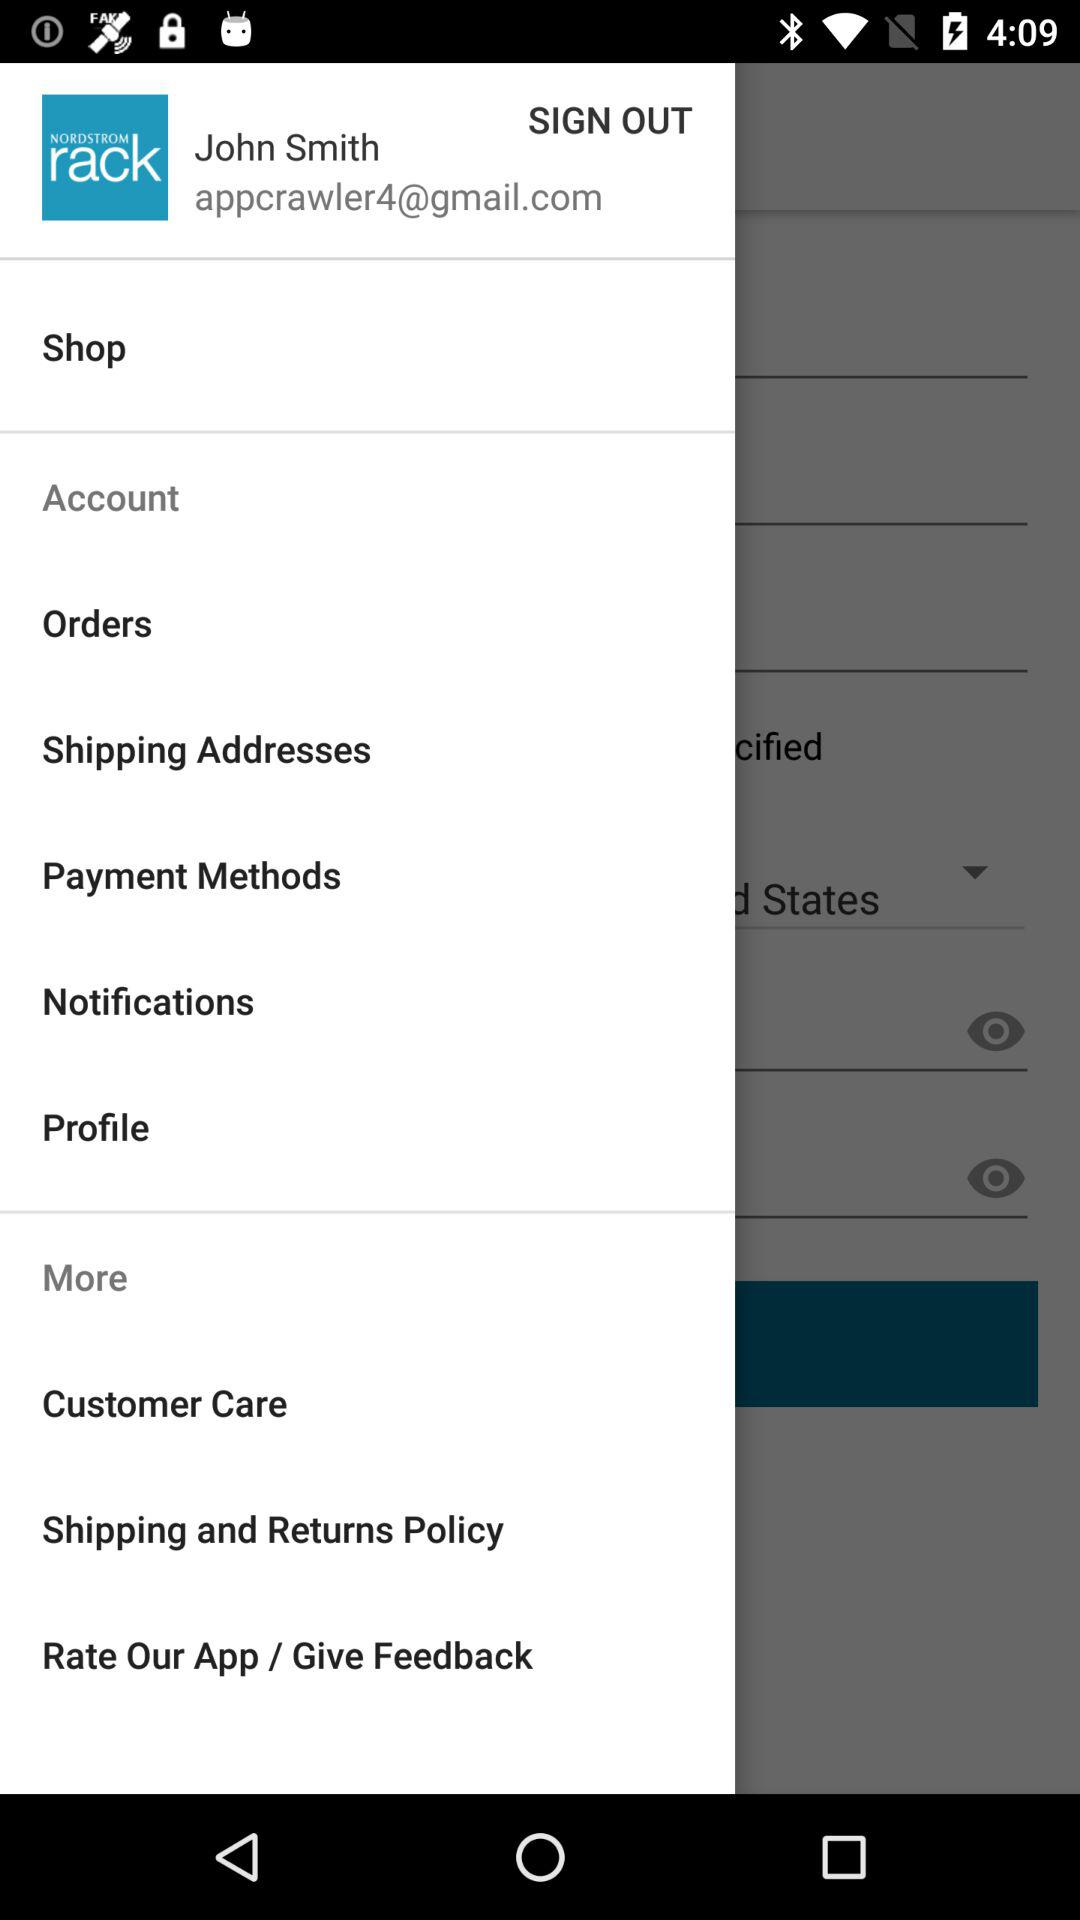What is the name of the user? The name of the user is John Smith. 